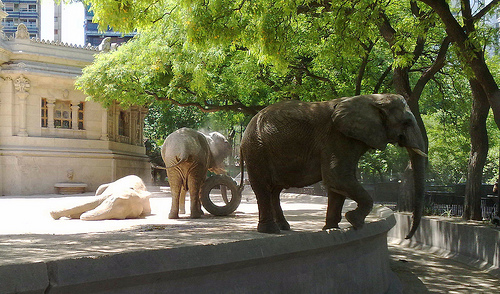What time of day does it appear to be in the image? Given the bright sunlight and the shadows casted by the trees and elephants, it appears to be midday. What is the elephant standing up doing? The standing elephant seems to be calmly exploring its surroundings, perhaps enjoying the tranquility of the space it’s in. 